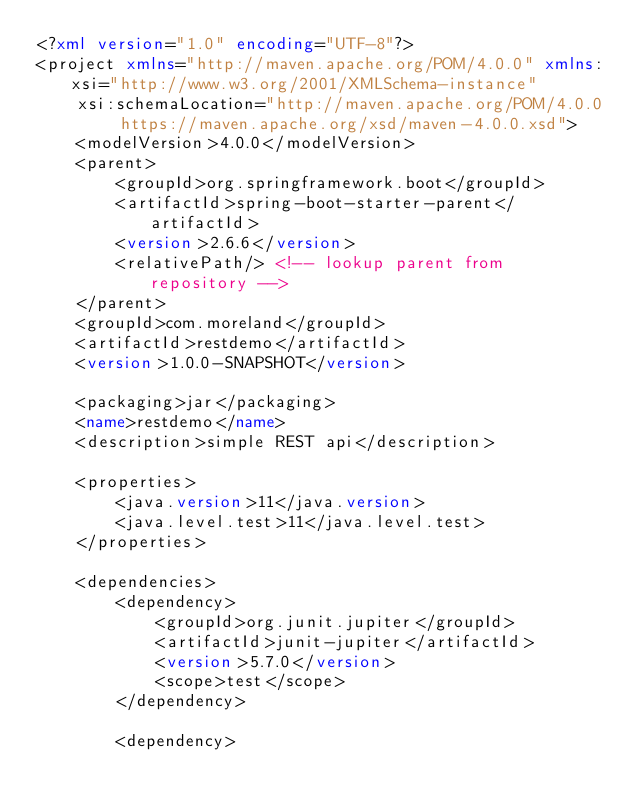<code> <loc_0><loc_0><loc_500><loc_500><_XML_><?xml version="1.0" encoding="UTF-8"?>
<project xmlns="http://maven.apache.org/POM/4.0.0" xmlns:xsi="http://www.w3.org/2001/XMLSchema-instance"
    xsi:schemaLocation="http://maven.apache.org/POM/4.0.0 https://maven.apache.org/xsd/maven-4.0.0.xsd">
    <modelVersion>4.0.0</modelVersion>
    <parent>
        <groupId>org.springframework.boot</groupId>
        <artifactId>spring-boot-starter-parent</artifactId>
        <version>2.6.6</version>
        <relativePath/> <!-- lookup parent from repository -->
    </parent>
    <groupId>com.moreland</groupId>
    <artifactId>restdemo</artifactId>
    <version>1.0.0-SNAPSHOT</version>

    <packaging>jar</packaging>
    <name>restdemo</name>
    <description>simple REST api</description>

    <properties>
        <java.version>11</java.version>
        <java.level.test>11</java.level.test>
    </properties>

    <dependencies>
        <dependency>
            <groupId>org.junit.jupiter</groupId>
            <artifactId>junit-jupiter</artifactId>
            <version>5.7.0</version>
            <scope>test</scope>
        </dependency>

        <dependency></code> 